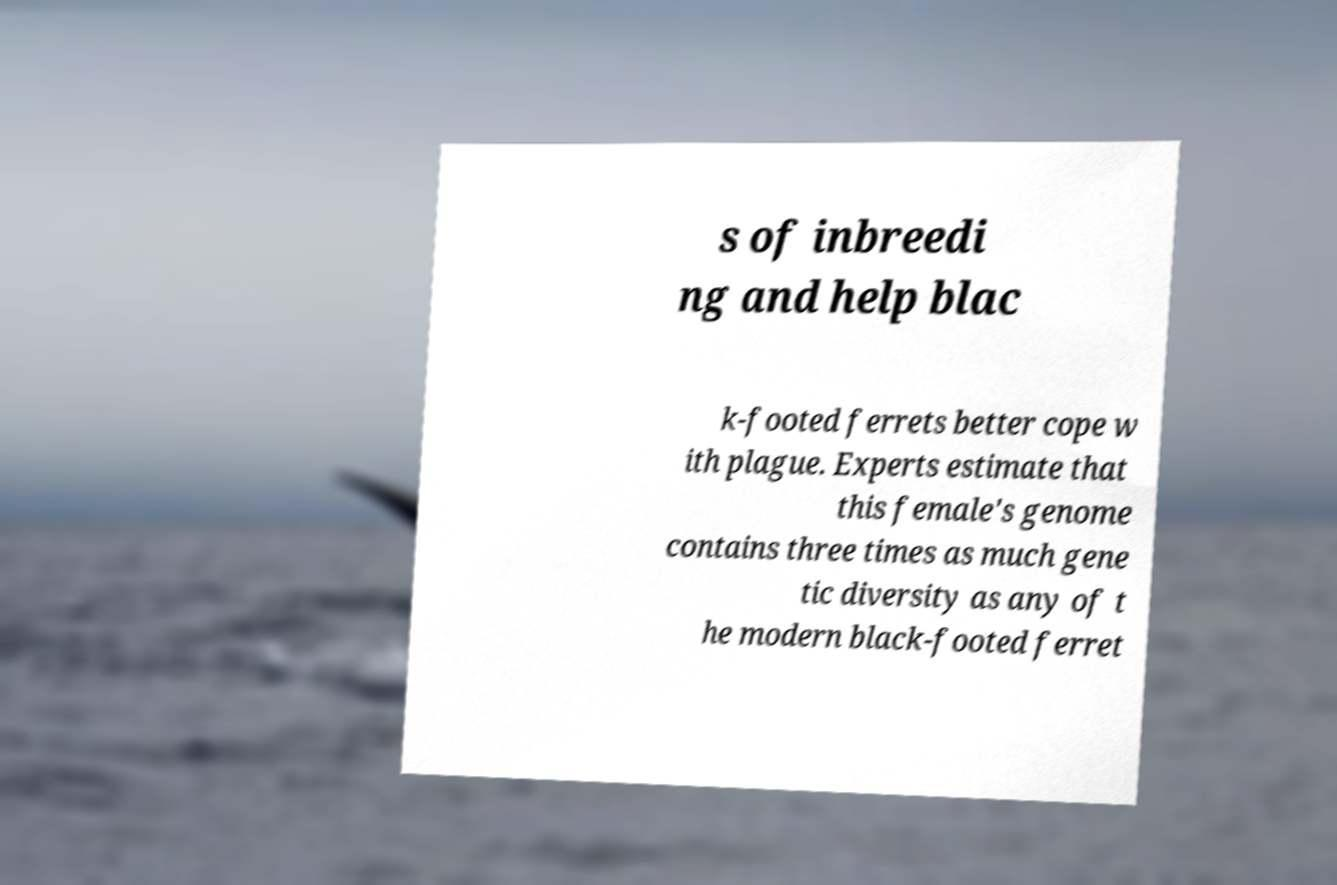Could you assist in decoding the text presented in this image and type it out clearly? s of inbreedi ng and help blac k-footed ferrets better cope w ith plague. Experts estimate that this female's genome contains three times as much gene tic diversity as any of t he modern black-footed ferret 